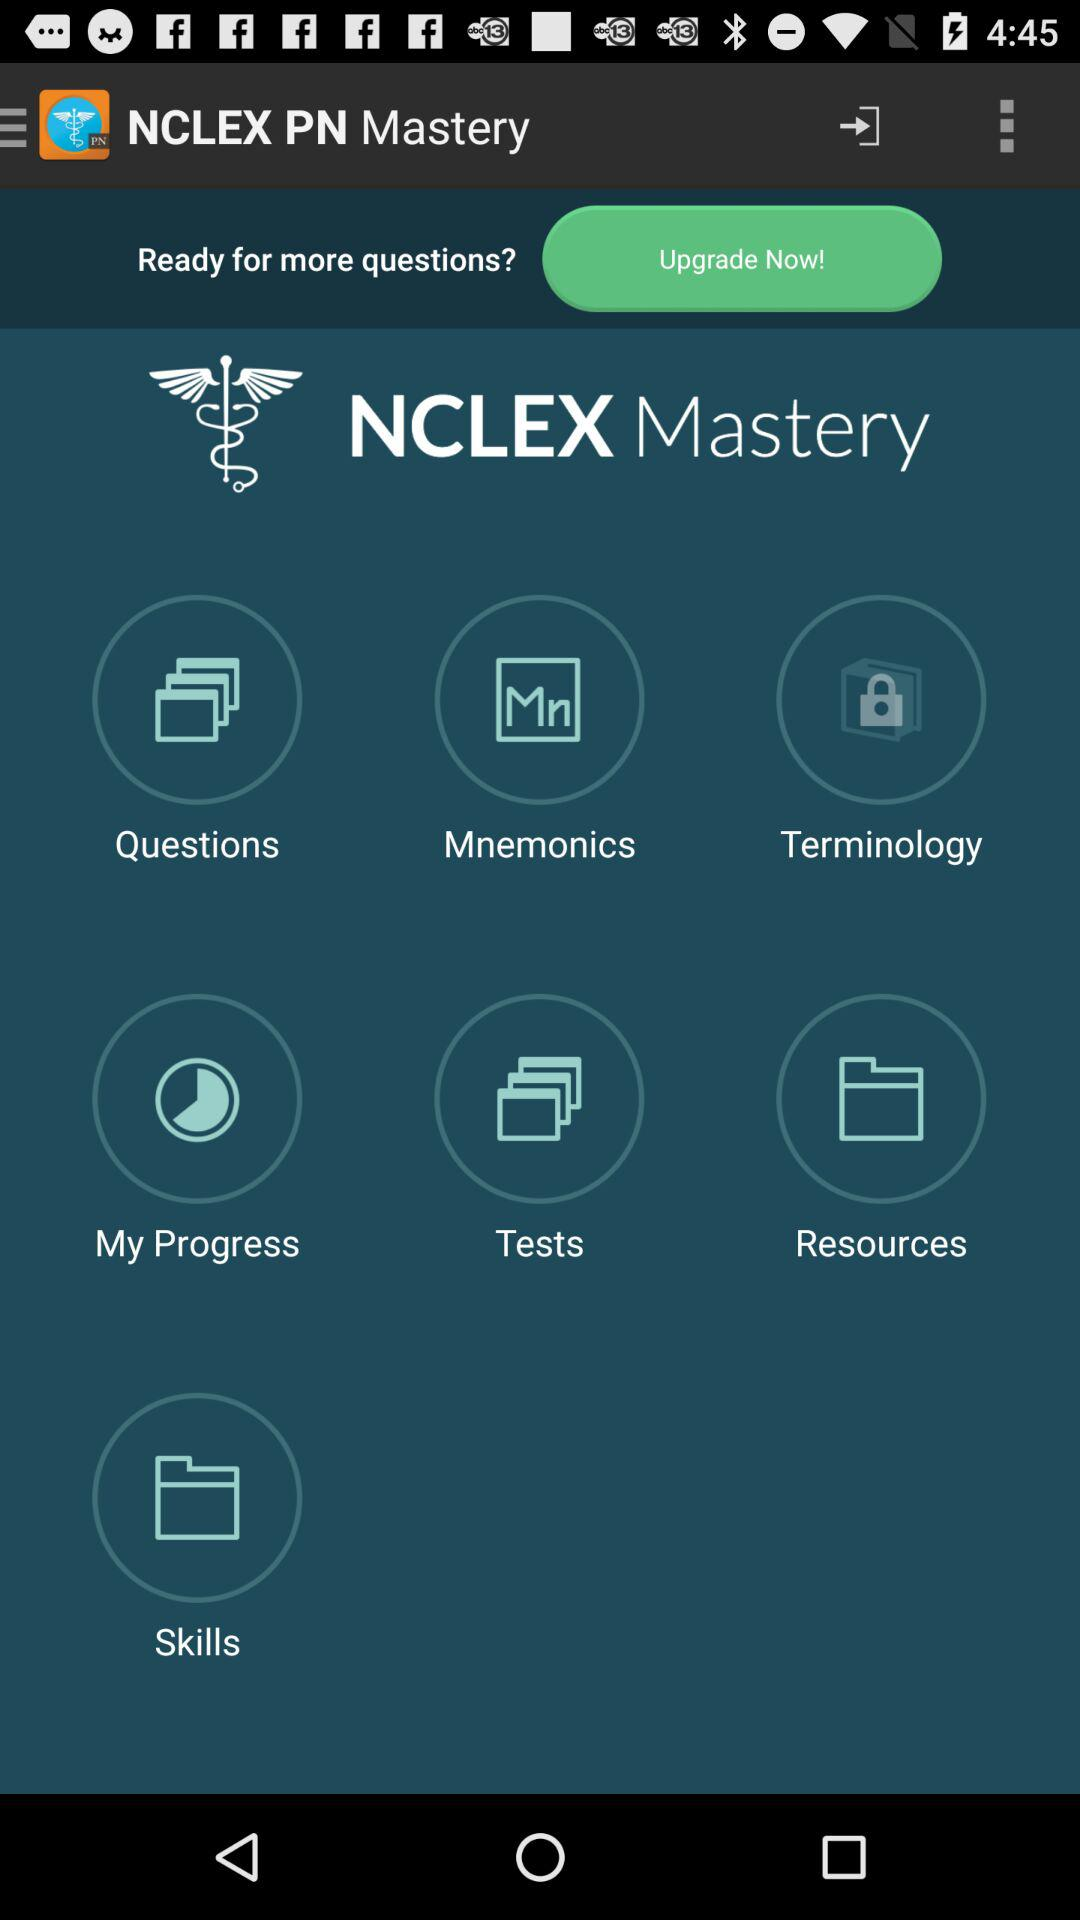What is the application name? The application name is "NCLEX PN Mastery". 